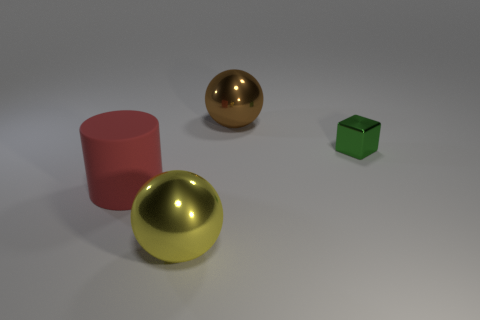Is there any other thing that is made of the same material as the big cylinder?
Keep it short and to the point. No. Are there more large shiny things that are behind the big matte cylinder than brown cubes?
Keep it short and to the point. Yes. Is the material of the sphere in front of the cube the same as the big cylinder?
Offer a very short reply. No. What is the size of the object on the left side of the big metallic object to the left of the big thing that is behind the large red cylinder?
Offer a very short reply. Large. The yellow thing that is made of the same material as the small block is what size?
Provide a short and direct response. Large. What color is the object that is both in front of the small green block and behind the yellow ball?
Keep it short and to the point. Red. There is a green object behind the large yellow shiny object; does it have the same shape as the metal thing behind the tiny thing?
Provide a succinct answer. No. There is a large thing on the left side of the big yellow metal object; what material is it?
Give a very brief answer. Rubber. How many things are big metal spheres that are to the right of the big yellow metal ball or small metal cylinders?
Offer a very short reply. 1. Is the number of big rubber things that are behind the red thing the same as the number of shiny objects?
Make the answer very short. No. 